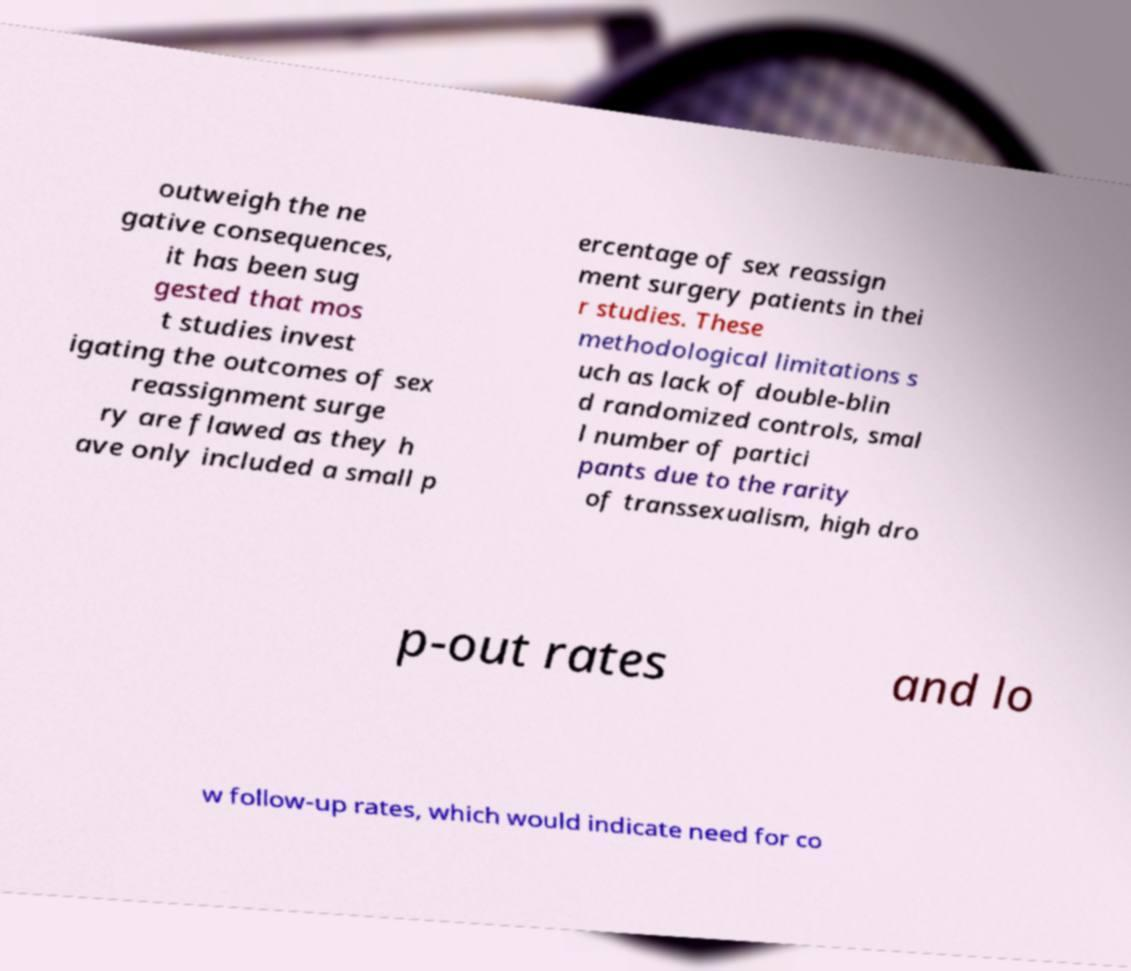For documentation purposes, I need the text within this image transcribed. Could you provide that? outweigh the ne gative consequences, it has been sug gested that mos t studies invest igating the outcomes of sex reassignment surge ry are flawed as they h ave only included a small p ercentage of sex reassign ment surgery patients in thei r studies. These methodological limitations s uch as lack of double-blin d randomized controls, smal l number of partici pants due to the rarity of transsexualism, high dro p-out rates and lo w follow-up rates, which would indicate need for co 